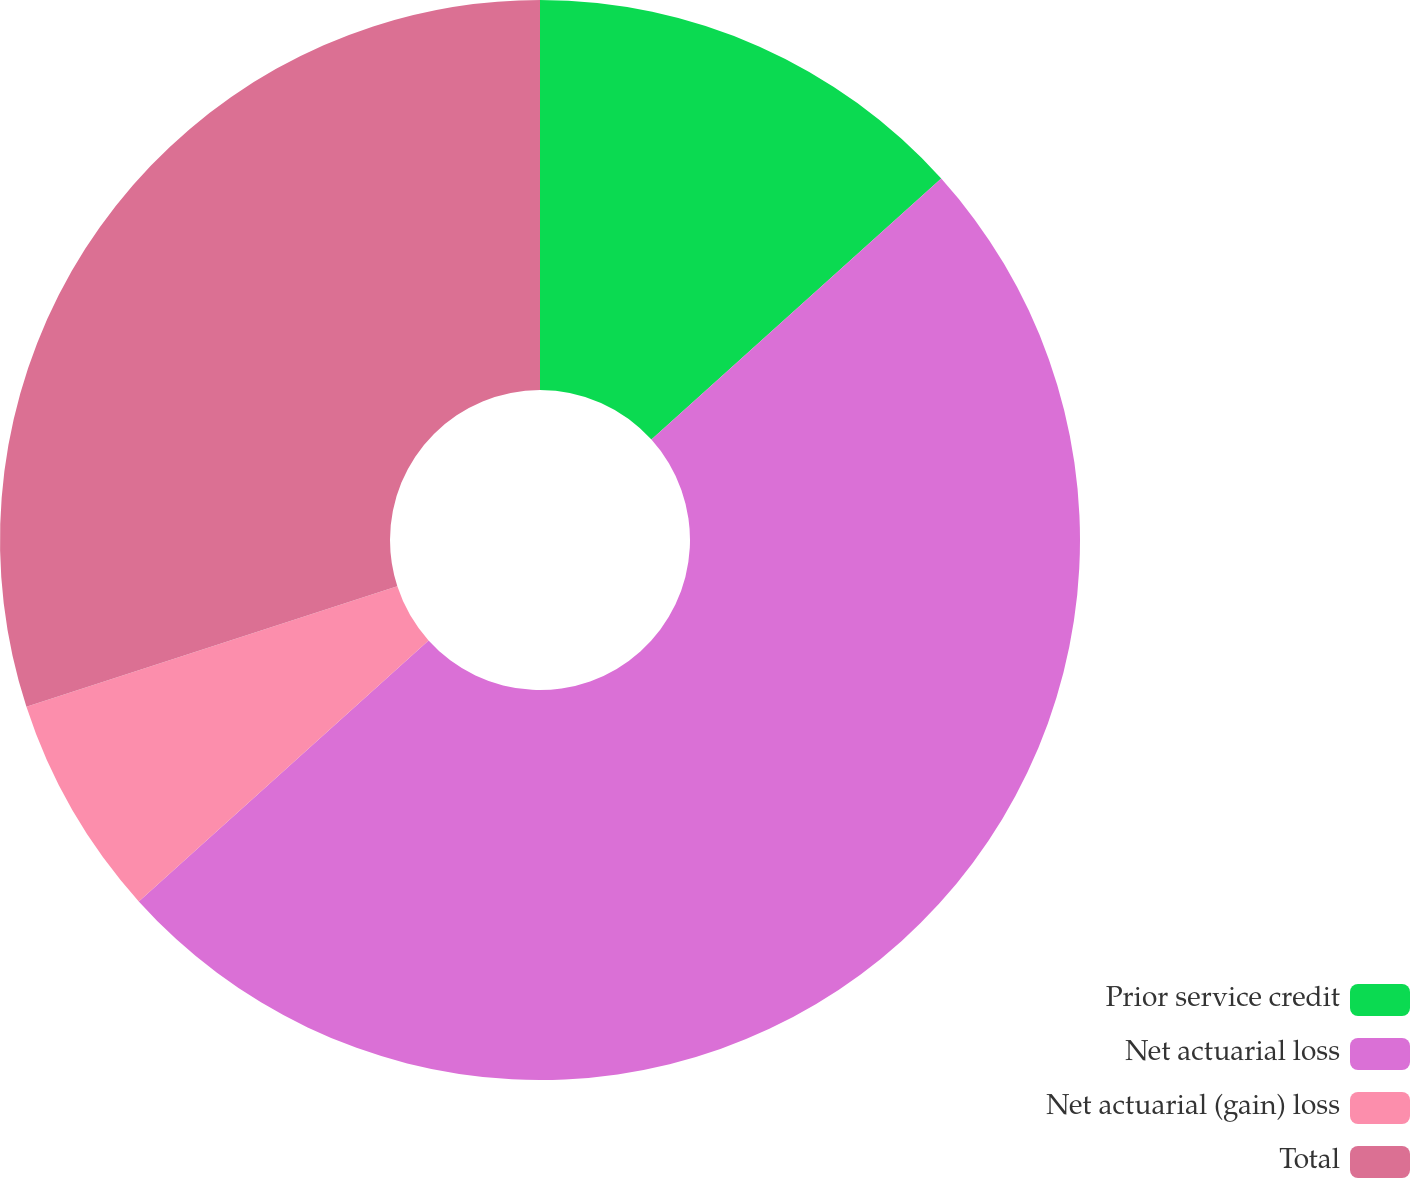Convert chart to OTSL. <chart><loc_0><loc_0><loc_500><loc_500><pie_chart><fcel>Prior service credit<fcel>Net actuarial loss<fcel>Net actuarial (gain) loss<fcel>Total<nl><fcel>13.33%<fcel>50.0%<fcel>6.67%<fcel>30.0%<nl></chart> 